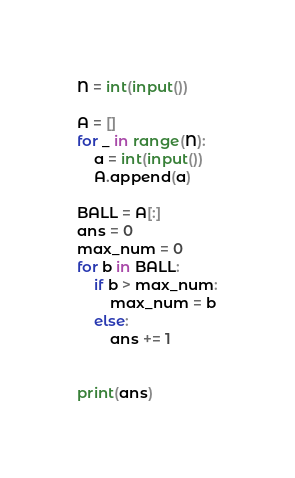<code> <loc_0><loc_0><loc_500><loc_500><_Python_>N = int(input())

A = []
for _ in range(N):
    a = int(input())
    A.append(a)
    
BALL = A[:]
ans = 0
max_num = 0
for b in BALL:
    if b > max_num:
        max_num = b
    else:
        ans += 1

    
print(ans)</code> 